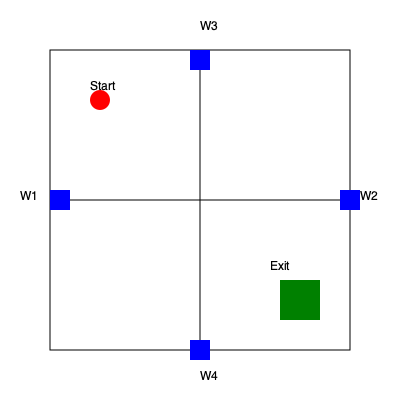You're in a building during an auction when a security breach occurs. The floor plan above shows your current position (red circle) and the nearest exit (green square). There are four windows (W1, W2, W3, W4) marked in blue. Calculate the shortest path to the exit, considering that you can move horizontally, vertically, or diagonally. What is the minimum distance you need to cover? To find the shortest path, we'll consider both direct movement and potential shortcuts through windows:

1. Direct path:
   - Start coordinates: (100, 100)
   - Exit coordinates: (300, 300)
   - Distance = $\sqrt{(300-100)^2 + (300-100)^2} = \sqrt{40000} = 200$ units

2. Path through W1 (50, 200):
   - Distance to W1 = $\sqrt{(50-100)^2 + (200-100)^2} = \sqrt{12500} \approx 111.8$ units
   - Distance from W1 to exit = $\sqrt{(300-50)^2 + (300-200)^2} = \sqrt{62500} = 250$ units
   - Total: 361.8 units

3. Path through W2 (350, 200):
   - Distance to W2 = $\sqrt{(350-100)^2 + (200-100)^2} = \sqrt{72500} \approx 269.3$ units
   - Distance from W2 to exit = $\sqrt{(300-350)^2 + (300-200)^2} = \sqrt{12500} = 111.8$ units
   - Total: 381.1 units

4. Path through W3 (200, 50):
   - Distance to W3 = $\sqrt{(200-100)^2 + (50-100)^2} = \sqrt{12500} \approx 111.8$ units
   - Distance from W3 to exit = $\sqrt{(300-200)^2 + (300-50)^2} = \sqrt{62500} = 250$ units
   - Total: 361.8 units

5. Path through W4 (200, 350):
   - Distance to W4 = $\sqrt{(200-100)^2 + (350-100)^2} = \sqrt{72500} \approx 269.3$ units
   - Distance from W4 to exit = $\sqrt{(300-200)^2 + (300-350)^2} = \sqrt{12500} = 111.8$ units
   - Total: 381.1 units

The direct path (option 1) is the shortest at 200 units.
Answer: 200 units 